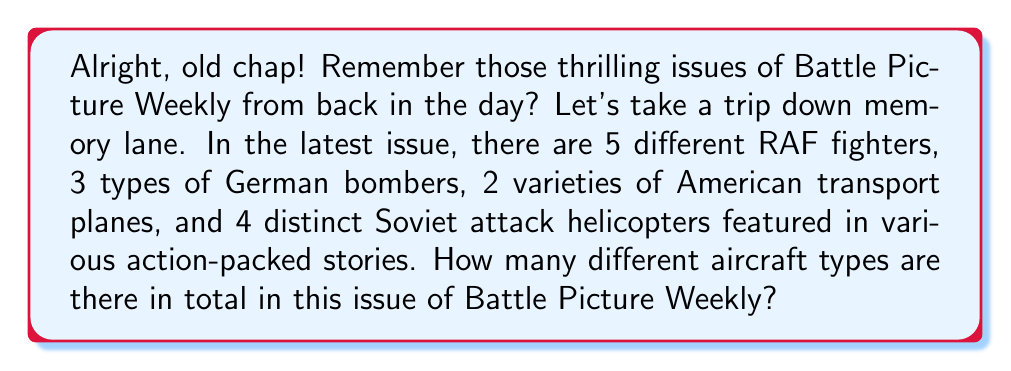Help me with this question. To solve this problem, we need to use the basic principle of counting. We'll add up the number of different aircraft types from each category:

1. RAF fighters: 5
2. German bombers: 3
3. American transport planes: 2
4. Soviet attack helicopters: 4

The total number of different aircraft types is the sum of these categories:

$$ \text{Total} = 5 + 3 + 2 + 4 $$

$$ \text{Total} = 14 $$

This straightforward addition gives us the total count of different aircraft types featured in this issue of Battle Picture Weekly.
Answer: 14 different aircraft types 